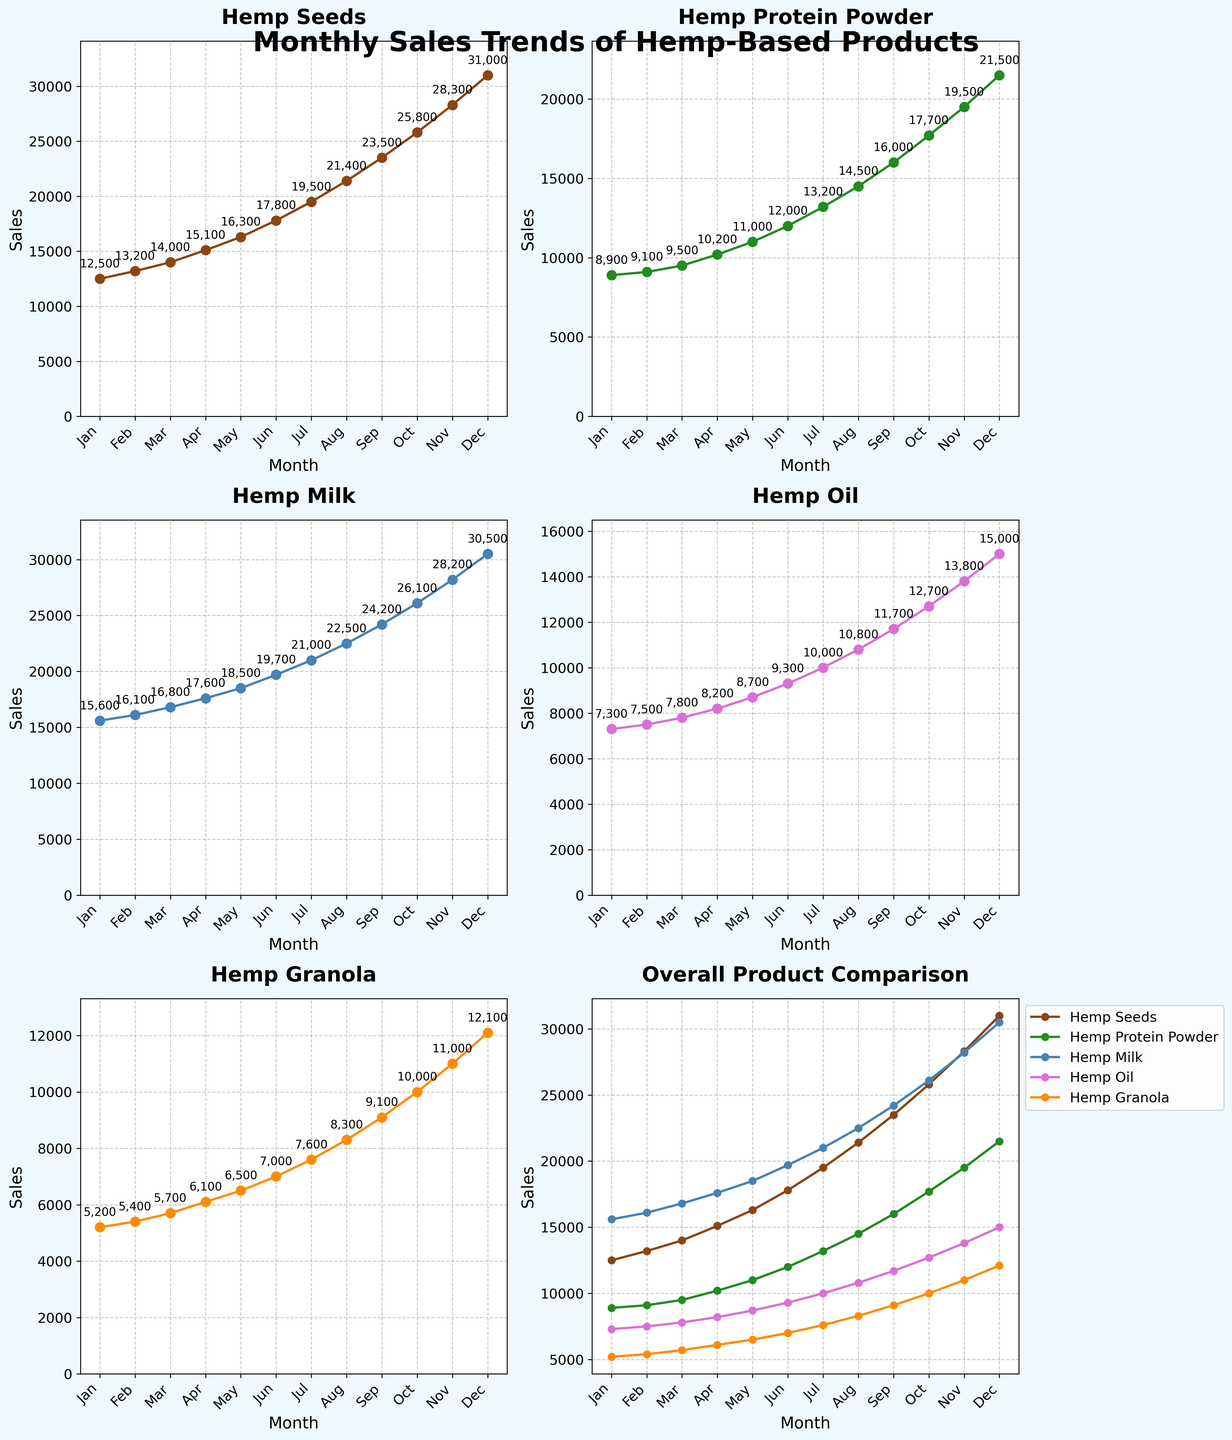Which product has the highest sales in January and what is the value? Look at the first subplot for each product and find the highest point in January. The product with the highest value of all the products should be noted.
Answer: Hemp Milk, 15600 How do the sales of Hemp Protein Powder in March compare to those in August? Find the sales value of Hemp Protein Powder in March and August from the respective subplots and compare them.
Answer: March: 9500, August: 14500. August is higher Which month shows the highest sales across all products? Identify the month with the highest value among all the individual plots for each product. The month with the most frequent appearance as the highest point within each subplot is the answer.
Answer: December What is the overall trend of Hemp Granola sales throughout the year? Look at the subplot for Hemp Granola and observe the pattern of the sales values from January to December.
Answer: Increasing trend Compare the sales of Hemp Seeds and Hemp Oil in November. Which one is higher? Check the sales values in November for both Hemp Seeds and Hemp Oil from their respective plots and compare them.
Answer: Hemp Seeds What is the average monthly sales for Hemp Milk over the entire year? Sum the sales values for Hemp Milk for all months from its subplot and divide by 12. Detailed steps: (15600+16100+16800+17600+18500+19700+21000+22500+24200+26100+28200+30500) / 12.
Answer: 21425 Which product had the greatest increase in sales from January to December? Calculate the difference in sales from January to December for each product and identify which one has the highest difference. Detailed steps: (31000-12500) for Hemp Seeds, (21500-8900) for Hemp Protein Powder, (30500-15600) for Hemp Milk, (15000-7300) for Hemp Oil, and (12100-5200) for Hemp Granola.
Answer: Hemp Milk (14900) What is the overall trend comparison of all products combined? Observe the overall trend subplot which compares all products and describe the general pattern.
Answer: Increasing trend 